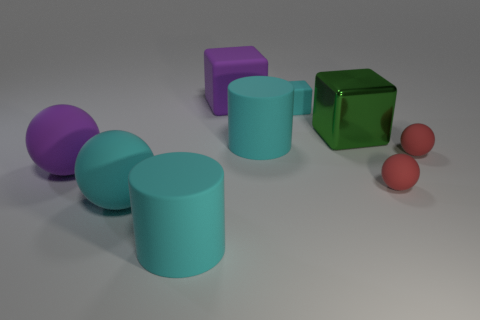Is there a purple rubber thing that has the same shape as the large shiny object?
Give a very brief answer. Yes. Are the purple ball and the cube in front of the tiny matte cube made of the same material?
Ensure brevity in your answer.  No. The cylinder that is on the left side of the big cyan matte cylinder that is on the right side of the large purple matte thing behind the tiny cyan block is what color?
Keep it short and to the point. Cyan. What material is the green cube that is the same size as the cyan rubber sphere?
Offer a terse response. Metal. What number of cylinders have the same material as the big purple block?
Make the answer very short. 2. There is a cube left of the cyan matte cube; is its size the same as the purple thing that is in front of the big green metal thing?
Provide a short and direct response. Yes. What color is the large thing that is behind the big green metal object?
Ensure brevity in your answer.  Purple. What material is the object that is the same color as the big rubber block?
Provide a short and direct response. Rubber. What number of big objects have the same color as the shiny block?
Your response must be concise. 0. Is the size of the purple ball the same as the rubber cube that is right of the purple rubber block?
Provide a succinct answer. No. 